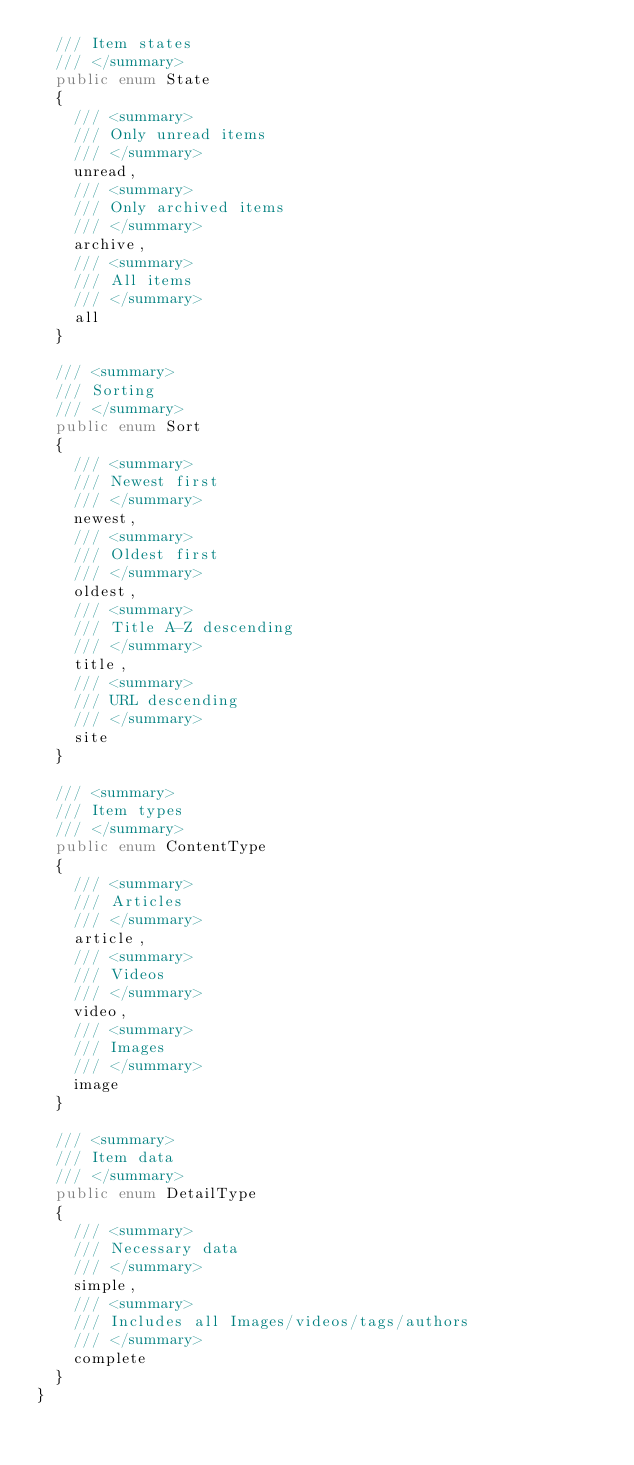<code> <loc_0><loc_0><loc_500><loc_500><_C#_>  /// Item states
  /// </summary>
  public enum State
  {
    /// <summary>
    /// Only unread items
    /// </summary>
    unread,
    /// <summary>
    /// Only archived items
    /// </summary>
    archive,
    /// <summary>
    /// All items
    /// </summary>
    all
  }

  /// <summary>
  /// Sorting
  /// </summary>
  public enum Sort
  {
    /// <summary>
    /// Newest first
    /// </summary>
    newest,
    /// <summary>
    /// Oldest first
    /// </summary>
    oldest,
    /// <summary>
    /// Title A-Z descending
    /// </summary>
    title,
    /// <summary>
    /// URL descending
    /// </summary>
    site
  }

  /// <summary>
  /// Item types
  /// </summary>
  public enum ContentType
  {
    /// <summary>
    /// Articles
    /// </summary>
    article,
    /// <summary>
    /// Videos
    /// </summary>
    video,
    /// <summary>
    /// Images
    /// </summary>
    image
  }

  /// <summary>
  /// Item data
  /// </summary>
  public enum DetailType
  {
    /// <summary>
    /// Necessary data
    /// </summary>
    simple,
    /// <summary>
    /// Includes all Images/videos/tags/authors
    /// </summary>
    complete
  }
}
</code> 